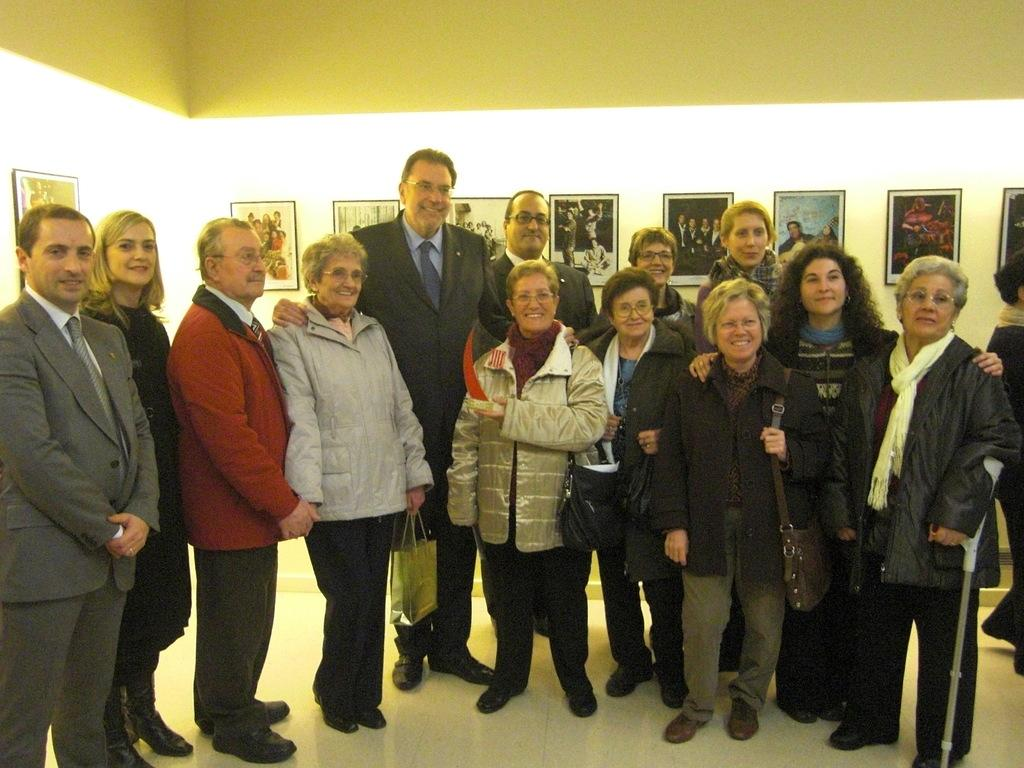How many people are the people are in the image? There is a group of people in the image. What are the people doing in the image? The people are standing on the floor and smiling. What objects can be seen in the image besides the people? There is a hand stick and bags visible in the image. What can be seen in the background of the image? There are frames on the wall in the background of the image. What type of ornament is hanging from the door in the image? There is no door or ornament present in the image. What year is depicted in the image? The image does not depict a specific year; it is a snapshot of a moment in time. 